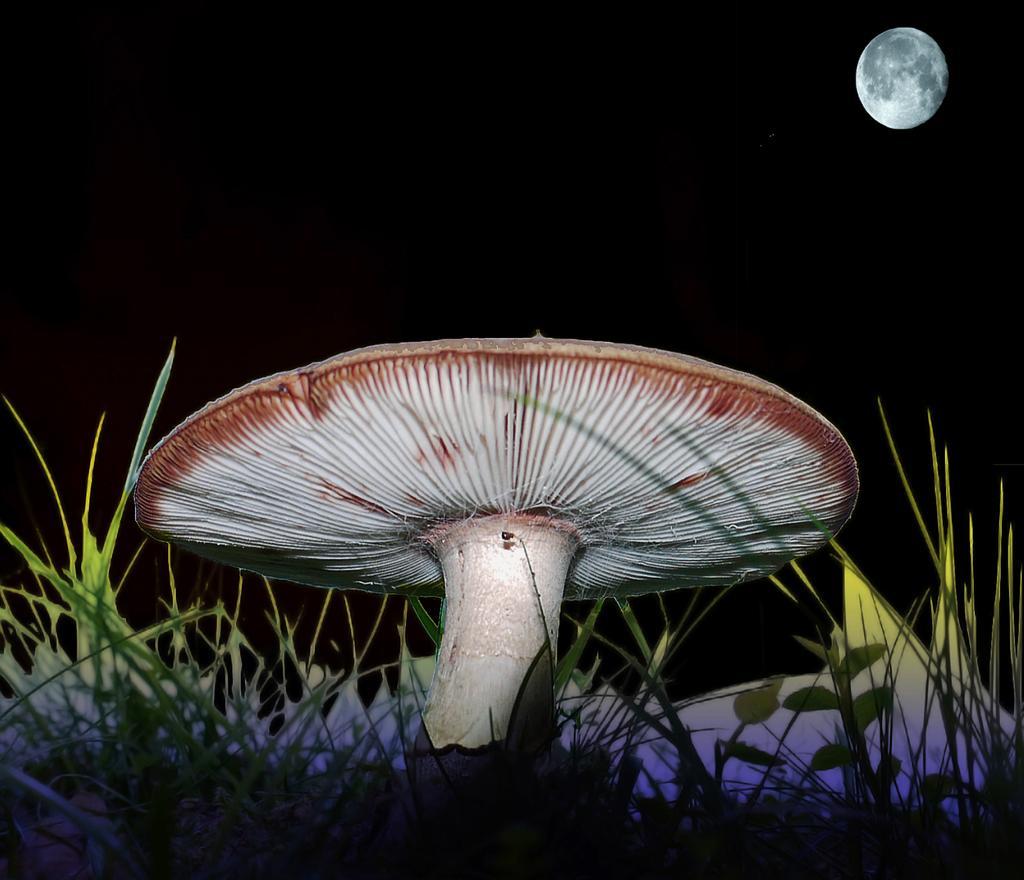How would you summarize this image in a sentence or two? It is a mushroom, this is the grass, on right side there is a moon. 